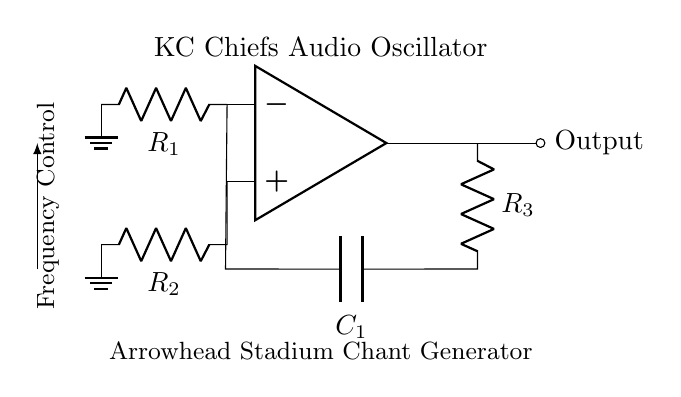What type of oscillator is represented in the circuit? The circuit is an audio oscillator, indicated by the design and labeling on the diagram for generating audio frequencies associated with crowd chants.
Answer: audio oscillator What components are used to control the frequency? The frequency control is primarily managed by the resistor R3 and capacitor C1, which determine the oscillation frequency based on their values.
Answer: R3 and C1 What is the output labeled as in the circuit diagram? The output is labeled as Output, indicating where the audio signal will be emitted from the circuit to produce sound.
Answer: Output How many resistors are in the circuit? The circuit contains three resistors, R1, R2, and R3, as clearly indicated in the diagram.
Answer: 3 What does the op amp denote in the circuit? The op amp serves as the main amplification component, transforming the input signals to produce the oscillating output required for audio tones.
Answer: amplification component Why is the ground connected to both R1 and R2? The ground connections to R1 and R2 establish a reference point for voltage in the circuit, necessary for the op amp to function correctly and stabilize the oscillation.
Answer: reference point What is the significance of the node labeled 'KC Chiefs Audio Oscillator'? This label identifies the specific purpose of the circuit, which is to generate audio tones that emulate the crowd chants associated with the Kansas City Chiefs during games.
Answer: specific purpose of the circuit 